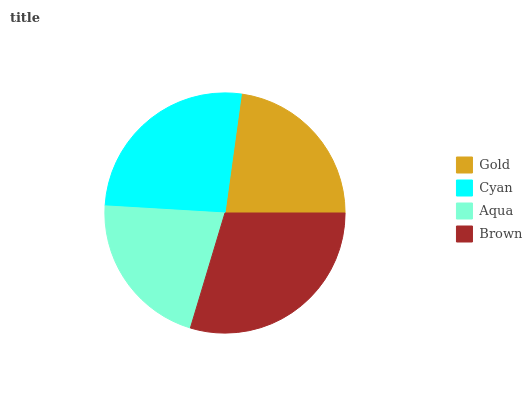Is Aqua the minimum?
Answer yes or no. Yes. Is Brown the maximum?
Answer yes or no. Yes. Is Cyan the minimum?
Answer yes or no. No. Is Cyan the maximum?
Answer yes or no. No. Is Cyan greater than Gold?
Answer yes or no. Yes. Is Gold less than Cyan?
Answer yes or no. Yes. Is Gold greater than Cyan?
Answer yes or no. No. Is Cyan less than Gold?
Answer yes or no. No. Is Cyan the high median?
Answer yes or no. Yes. Is Gold the low median?
Answer yes or no. Yes. Is Brown the high median?
Answer yes or no. No. Is Brown the low median?
Answer yes or no. No. 